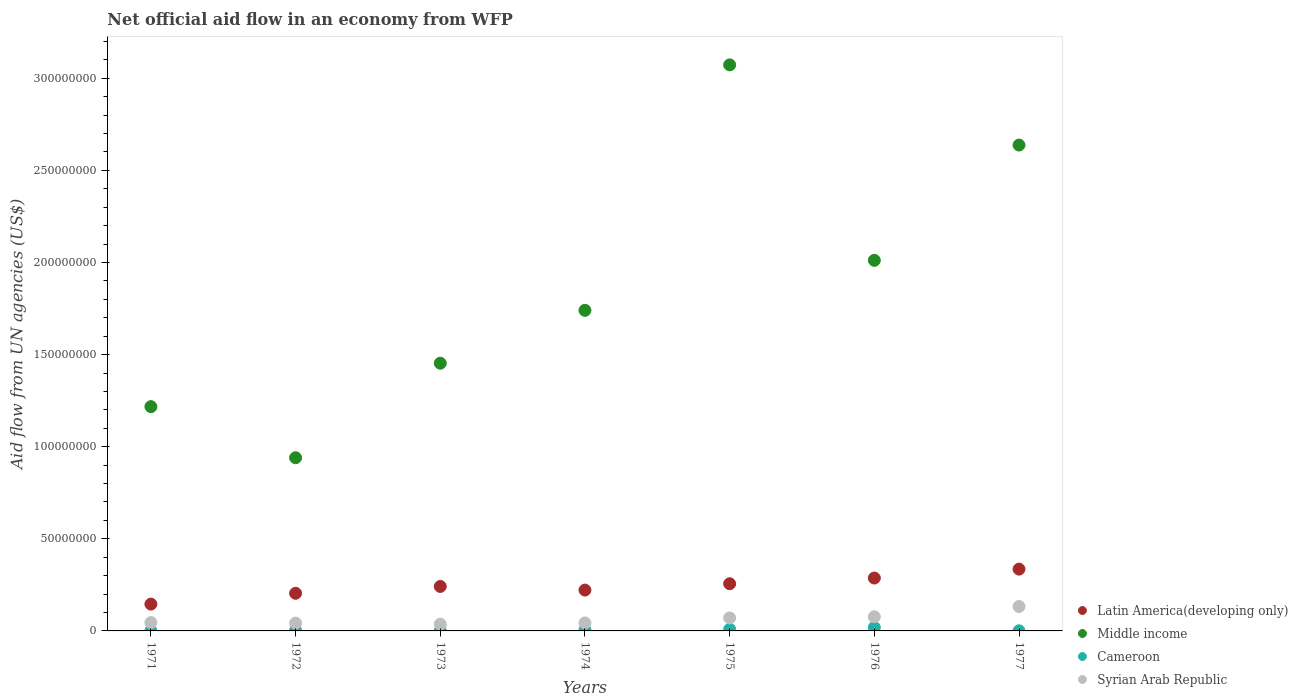How many different coloured dotlines are there?
Your answer should be very brief. 4. Is the number of dotlines equal to the number of legend labels?
Provide a succinct answer. Yes. What is the net official aid flow in Syrian Arab Republic in 1976?
Make the answer very short. 7.68e+06. Across all years, what is the maximum net official aid flow in Middle income?
Your answer should be compact. 3.07e+08. Across all years, what is the minimum net official aid flow in Latin America(developing only)?
Your answer should be very brief. 1.46e+07. In which year was the net official aid flow in Latin America(developing only) minimum?
Your answer should be compact. 1971. What is the total net official aid flow in Middle income in the graph?
Offer a terse response. 1.31e+09. What is the difference between the net official aid flow in Syrian Arab Republic in 1972 and that in 1976?
Offer a terse response. -3.42e+06. What is the difference between the net official aid flow in Syrian Arab Republic in 1975 and the net official aid flow in Cameroon in 1972?
Ensure brevity in your answer.  6.81e+06. What is the average net official aid flow in Syrian Arab Republic per year?
Ensure brevity in your answer.  6.39e+06. In the year 1977, what is the difference between the net official aid flow in Latin America(developing only) and net official aid flow in Cameroon?
Your answer should be compact. 3.35e+07. In how many years, is the net official aid flow in Latin America(developing only) greater than 90000000 US$?
Your answer should be compact. 0. What is the ratio of the net official aid flow in Cameroon in 1972 to that in 1976?
Your response must be concise. 0.13. Is the net official aid flow in Latin America(developing only) in 1976 less than that in 1977?
Offer a terse response. Yes. What is the difference between the highest and the second highest net official aid flow in Syrian Arab Republic?
Offer a very short reply. 5.57e+06. What is the difference between the highest and the lowest net official aid flow in Middle income?
Offer a terse response. 2.13e+08. In how many years, is the net official aid flow in Latin America(developing only) greater than the average net official aid flow in Latin America(developing only) taken over all years?
Provide a succinct answer. 3. Is the net official aid flow in Middle income strictly greater than the net official aid flow in Cameroon over the years?
Offer a terse response. Yes. Is the net official aid flow in Syrian Arab Republic strictly less than the net official aid flow in Middle income over the years?
Keep it short and to the point. Yes. How many dotlines are there?
Make the answer very short. 4. How many years are there in the graph?
Offer a terse response. 7. What is the difference between two consecutive major ticks on the Y-axis?
Your answer should be compact. 5.00e+07. Are the values on the major ticks of Y-axis written in scientific E-notation?
Give a very brief answer. No. Where does the legend appear in the graph?
Ensure brevity in your answer.  Bottom right. What is the title of the graph?
Keep it short and to the point. Net official aid flow in an economy from WFP. What is the label or title of the X-axis?
Ensure brevity in your answer.  Years. What is the label or title of the Y-axis?
Offer a very short reply. Aid flow from UN agencies (US$). What is the Aid flow from UN agencies (US$) in Latin America(developing only) in 1971?
Provide a short and direct response. 1.46e+07. What is the Aid flow from UN agencies (US$) in Middle income in 1971?
Your answer should be compact. 1.22e+08. What is the Aid flow from UN agencies (US$) of Cameroon in 1971?
Offer a very short reply. 9.00e+04. What is the Aid flow from UN agencies (US$) in Syrian Arab Republic in 1971?
Give a very brief answer. 4.53e+06. What is the Aid flow from UN agencies (US$) in Latin America(developing only) in 1972?
Your answer should be compact. 2.04e+07. What is the Aid flow from UN agencies (US$) of Middle income in 1972?
Your answer should be compact. 9.40e+07. What is the Aid flow from UN agencies (US$) of Cameroon in 1972?
Provide a short and direct response. 2.40e+05. What is the Aid flow from UN agencies (US$) in Syrian Arab Republic in 1972?
Offer a very short reply. 4.26e+06. What is the Aid flow from UN agencies (US$) in Latin America(developing only) in 1973?
Give a very brief answer. 2.42e+07. What is the Aid flow from UN agencies (US$) in Middle income in 1973?
Keep it short and to the point. 1.45e+08. What is the Aid flow from UN agencies (US$) in Syrian Arab Republic in 1973?
Ensure brevity in your answer.  3.66e+06. What is the Aid flow from UN agencies (US$) in Latin America(developing only) in 1974?
Ensure brevity in your answer.  2.22e+07. What is the Aid flow from UN agencies (US$) of Middle income in 1974?
Make the answer very short. 1.74e+08. What is the Aid flow from UN agencies (US$) of Cameroon in 1974?
Provide a succinct answer. 5.40e+05. What is the Aid flow from UN agencies (US$) in Syrian Arab Republic in 1974?
Keep it short and to the point. 4.33e+06. What is the Aid flow from UN agencies (US$) in Latin America(developing only) in 1975?
Give a very brief answer. 2.56e+07. What is the Aid flow from UN agencies (US$) in Middle income in 1975?
Give a very brief answer. 3.07e+08. What is the Aid flow from UN agencies (US$) of Cameroon in 1975?
Offer a very short reply. 8.50e+05. What is the Aid flow from UN agencies (US$) of Syrian Arab Republic in 1975?
Provide a short and direct response. 7.05e+06. What is the Aid flow from UN agencies (US$) of Latin America(developing only) in 1976?
Make the answer very short. 2.87e+07. What is the Aid flow from UN agencies (US$) in Middle income in 1976?
Keep it short and to the point. 2.01e+08. What is the Aid flow from UN agencies (US$) of Cameroon in 1976?
Provide a succinct answer. 1.91e+06. What is the Aid flow from UN agencies (US$) in Syrian Arab Republic in 1976?
Make the answer very short. 7.68e+06. What is the Aid flow from UN agencies (US$) in Latin America(developing only) in 1977?
Offer a very short reply. 3.36e+07. What is the Aid flow from UN agencies (US$) of Middle income in 1977?
Your response must be concise. 2.64e+08. What is the Aid flow from UN agencies (US$) of Syrian Arab Republic in 1977?
Keep it short and to the point. 1.32e+07. Across all years, what is the maximum Aid flow from UN agencies (US$) in Latin America(developing only)?
Keep it short and to the point. 3.36e+07. Across all years, what is the maximum Aid flow from UN agencies (US$) in Middle income?
Ensure brevity in your answer.  3.07e+08. Across all years, what is the maximum Aid flow from UN agencies (US$) of Cameroon?
Provide a short and direct response. 1.91e+06. Across all years, what is the maximum Aid flow from UN agencies (US$) of Syrian Arab Republic?
Give a very brief answer. 1.32e+07. Across all years, what is the minimum Aid flow from UN agencies (US$) of Latin America(developing only)?
Ensure brevity in your answer.  1.46e+07. Across all years, what is the minimum Aid flow from UN agencies (US$) in Middle income?
Provide a succinct answer. 9.40e+07. Across all years, what is the minimum Aid flow from UN agencies (US$) of Syrian Arab Republic?
Keep it short and to the point. 3.66e+06. What is the total Aid flow from UN agencies (US$) in Latin America(developing only) in the graph?
Provide a short and direct response. 1.69e+08. What is the total Aid flow from UN agencies (US$) in Middle income in the graph?
Your response must be concise. 1.31e+09. What is the total Aid flow from UN agencies (US$) of Cameroon in the graph?
Offer a terse response. 3.81e+06. What is the total Aid flow from UN agencies (US$) of Syrian Arab Republic in the graph?
Offer a terse response. 4.48e+07. What is the difference between the Aid flow from UN agencies (US$) of Latin America(developing only) in 1971 and that in 1972?
Your answer should be very brief. -5.87e+06. What is the difference between the Aid flow from UN agencies (US$) of Middle income in 1971 and that in 1972?
Make the answer very short. 2.77e+07. What is the difference between the Aid flow from UN agencies (US$) of Syrian Arab Republic in 1971 and that in 1972?
Keep it short and to the point. 2.70e+05. What is the difference between the Aid flow from UN agencies (US$) of Latin America(developing only) in 1971 and that in 1973?
Provide a succinct answer. -9.59e+06. What is the difference between the Aid flow from UN agencies (US$) in Middle income in 1971 and that in 1973?
Offer a very short reply. -2.36e+07. What is the difference between the Aid flow from UN agencies (US$) of Syrian Arab Republic in 1971 and that in 1973?
Your response must be concise. 8.70e+05. What is the difference between the Aid flow from UN agencies (US$) of Latin America(developing only) in 1971 and that in 1974?
Make the answer very short. -7.61e+06. What is the difference between the Aid flow from UN agencies (US$) of Middle income in 1971 and that in 1974?
Your answer should be very brief. -5.23e+07. What is the difference between the Aid flow from UN agencies (US$) in Cameroon in 1971 and that in 1974?
Provide a succinct answer. -4.50e+05. What is the difference between the Aid flow from UN agencies (US$) in Syrian Arab Republic in 1971 and that in 1974?
Make the answer very short. 2.00e+05. What is the difference between the Aid flow from UN agencies (US$) in Latin America(developing only) in 1971 and that in 1975?
Give a very brief answer. -1.11e+07. What is the difference between the Aid flow from UN agencies (US$) of Middle income in 1971 and that in 1975?
Offer a terse response. -1.86e+08. What is the difference between the Aid flow from UN agencies (US$) in Cameroon in 1971 and that in 1975?
Your answer should be compact. -7.60e+05. What is the difference between the Aid flow from UN agencies (US$) in Syrian Arab Republic in 1971 and that in 1975?
Ensure brevity in your answer.  -2.52e+06. What is the difference between the Aid flow from UN agencies (US$) of Latin America(developing only) in 1971 and that in 1976?
Offer a very short reply. -1.42e+07. What is the difference between the Aid flow from UN agencies (US$) of Middle income in 1971 and that in 1976?
Your answer should be compact. -7.94e+07. What is the difference between the Aid flow from UN agencies (US$) in Cameroon in 1971 and that in 1976?
Offer a terse response. -1.82e+06. What is the difference between the Aid flow from UN agencies (US$) in Syrian Arab Republic in 1971 and that in 1976?
Offer a terse response. -3.15e+06. What is the difference between the Aid flow from UN agencies (US$) of Latin America(developing only) in 1971 and that in 1977?
Your response must be concise. -1.90e+07. What is the difference between the Aid flow from UN agencies (US$) of Middle income in 1971 and that in 1977?
Provide a short and direct response. -1.42e+08. What is the difference between the Aid flow from UN agencies (US$) of Cameroon in 1971 and that in 1977?
Give a very brief answer. 3.00e+04. What is the difference between the Aid flow from UN agencies (US$) of Syrian Arab Republic in 1971 and that in 1977?
Your response must be concise. -8.72e+06. What is the difference between the Aid flow from UN agencies (US$) in Latin America(developing only) in 1972 and that in 1973?
Your answer should be very brief. -3.72e+06. What is the difference between the Aid flow from UN agencies (US$) of Middle income in 1972 and that in 1973?
Offer a terse response. -5.13e+07. What is the difference between the Aid flow from UN agencies (US$) in Cameroon in 1972 and that in 1973?
Offer a terse response. 1.20e+05. What is the difference between the Aid flow from UN agencies (US$) of Syrian Arab Republic in 1972 and that in 1973?
Provide a succinct answer. 6.00e+05. What is the difference between the Aid flow from UN agencies (US$) in Latin America(developing only) in 1972 and that in 1974?
Provide a succinct answer. -1.74e+06. What is the difference between the Aid flow from UN agencies (US$) of Middle income in 1972 and that in 1974?
Provide a succinct answer. -8.00e+07. What is the difference between the Aid flow from UN agencies (US$) in Latin America(developing only) in 1972 and that in 1975?
Give a very brief answer. -5.19e+06. What is the difference between the Aid flow from UN agencies (US$) of Middle income in 1972 and that in 1975?
Your response must be concise. -2.13e+08. What is the difference between the Aid flow from UN agencies (US$) of Cameroon in 1972 and that in 1975?
Provide a short and direct response. -6.10e+05. What is the difference between the Aid flow from UN agencies (US$) in Syrian Arab Republic in 1972 and that in 1975?
Provide a succinct answer. -2.79e+06. What is the difference between the Aid flow from UN agencies (US$) in Latin America(developing only) in 1972 and that in 1976?
Offer a terse response. -8.28e+06. What is the difference between the Aid flow from UN agencies (US$) of Middle income in 1972 and that in 1976?
Your response must be concise. -1.07e+08. What is the difference between the Aid flow from UN agencies (US$) of Cameroon in 1972 and that in 1976?
Offer a very short reply. -1.67e+06. What is the difference between the Aid flow from UN agencies (US$) of Syrian Arab Republic in 1972 and that in 1976?
Make the answer very short. -3.42e+06. What is the difference between the Aid flow from UN agencies (US$) of Latin America(developing only) in 1972 and that in 1977?
Your answer should be very brief. -1.31e+07. What is the difference between the Aid flow from UN agencies (US$) in Middle income in 1972 and that in 1977?
Keep it short and to the point. -1.70e+08. What is the difference between the Aid flow from UN agencies (US$) in Cameroon in 1972 and that in 1977?
Offer a very short reply. 1.80e+05. What is the difference between the Aid flow from UN agencies (US$) of Syrian Arab Republic in 1972 and that in 1977?
Your answer should be compact. -8.99e+06. What is the difference between the Aid flow from UN agencies (US$) in Latin America(developing only) in 1973 and that in 1974?
Keep it short and to the point. 1.98e+06. What is the difference between the Aid flow from UN agencies (US$) in Middle income in 1973 and that in 1974?
Give a very brief answer. -2.87e+07. What is the difference between the Aid flow from UN agencies (US$) in Cameroon in 1973 and that in 1974?
Your answer should be very brief. -4.20e+05. What is the difference between the Aid flow from UN agencies (US$) of Syrian Arab Republic in 1973 and that in 1974?
Offer a very short reply. -6.70e+05. What is the difference between the Aid flow from UN agencies (US$) in Latin America(developing only) in 1973 and that in 1975?
Your answer should be very brief. -1.47e+06. What is the difference between the Aid flow from UN agencies (US$) in Middle income in 1973 and that in 1975?
Your answer should be very brief. -1.62e+08. What is the difference between the Aid flow from UN agencies (US$) of Cameroon in 1973 and that in 1975?
Your answer should be compact. -7.30e+05. What is the difference between the Aid flow from UN agencies (US$) of Syrian Arab Republic in 1973 and that in 1975?
Keep it short and to the point. -3.39e+06. What is the difference between the Aid flow from UN agencies (US$) in Latin America(developing only) in 1973 and that in 1976?
Keep it short and to the point. -4.56e+06. What is the difference between the Aid flow from UN agencies (US$) in Middle income in 1973 and that in 1976?
Your answer should be compact. -5.58e+07. What is the difference between the Aid flow from UN agencies (US$) in Cameroon in 1973 and that in 1976?
Provide a short and direct response. -1.79e+06. What is the difference between the Aid flow from UN agencies (US$) in Syrian Arab Republic in 1973 and that in 1976?
Give a very brief answer. -4.02e+06. What is the difference between the Aid flow from UN agencies (US$) of Latin America(developing only) in 1973 and that in 1977?
Make the answer very short. -9.40e+06. What is the difference between the Aid flow from UN agencies (US$) of Middle income in 1973 and that in 1977?
Your answer should be very brief. -1.18e+08. What is the difference between the Aid flow from UN agencies (US$) in Cameroon in 1973 and that in 1977?
Give a very brief answer. 6.00e+04. What is the difference between the Aid flow from UN agencies (US$) in Syrian Arab Republic in 1973 and that in 1977?
Your answer should be compact. -9.59e+06. What is the difference between the Aid flow from UN agencies (US$) of Latin America(developing only) in 1974 and that in 1975?
Provide a short and direct response. -3.45e+06. What is the difference between the Aid flow from UN agencies (US$) in Middle income in 1974 and that in 1975?
Your answer should be very brief. -1.33e+08. What is the difference between the Aid flow from UN agencies (US$) in Cameroon in 1974 and that in 1975?
Provide a succinct answer. -3.10e+05. What is the difference between the Aid flow from UN agencies (US$) in Syrian Arab Republic in 1974 and that in 1975?
Your response must be concise. -2.72e+06. What is the difference between the Aid flow from UN agencies (US$) of Latin America(developing only) in 1974 and that in 1976?
Provide a short and direct response. -6.54e+06. What is the difference between the Aid flow from UN agencies (US$) in Middle income in 1974 and that in 1976?
Provide a succinct answer. -2.72e+07. What is the difference between the Aid flow from UN agencies (US$) of Cameroon in 1974 and that in 1976?
Provide a succinct answer. -1.37e+06. What is the difference between the Aid flow from UN agencies (US$) of Syrian Arab Republic in 1974 and that in 1976?
Your answer should be compact. -3.35e+06. What is the difference between the Aid flow from UN agencies (US$) of Latin America(developing only) in 1974 and that in 1977?
Offer a terse response. -1.14e+07. What is the difference between the Aid flow from UN agencies (US$) in Middle income in 1974 and that in 1977?
Provide a short and direct response. -8.97e+07. What is the difference between the Aid flow from UN agencies (US$) of Syrian Arab Republic in 1974 and that in 1977?
Your answer should be compact. -8.92e+06. What is the difference between the Aid flow from UN agencies (US$) in Latin America(developing only) in 1975 and that in 1976?
Give a very brief answer. -3.09e+06. What is the difference between the Aid flow from UN agencies (US$) of Middle income in 1975 and that in 1976?
Keep it short and to the point. 1.06e+08. What is the difference between the Aid flow from UN agencies (US$) in Cameroon in 1975 and that in 1976?
Make the answer very short. -1.06e+06. What is the difference between the Aid flow from UN agencies (US$) of Syrian Arab Republic in 1975 and that in 1976?
Offer a terse response. -6.30e+05. What is the difference between the Aid flow from UN agencies (US$) in Latin America(developing only) in 1975 and that in 1977?
Provide a short and direct response. -7.93e+06. What is the difference between the Aid flow from UN agencies (US$) of Middle income in 1975 and that in 1977?
Give a very brief answer. 4.35e+07. What is the difference between the Aid flow from UN agencies (US$) of Cameroon in 1975 and that in 1977?
Your answer should be compact. 7.90e+05. What is the difference between the Aid flow from UN agencies (US$) of Syrian Arab Republic in 1975 and that in 1977?
Provide a succinct answer. -6.20e+06. What is the difference between the Aid flow from UN agencies (US$) in Latin America(developing only) in 1976 and that in 1977?
Keep it short and to the point. -4.84e+06. What is the difference between the Aid flow from UN agencies (US$) in Middle income in 1976 and that in 1977?
Ensure brevity in your answer.  -6.26e+07. What is the difference between the Aid flow from UN agencies (US$) of Cameroon in 1976 and that in 1977?
Your response must be concise. 1.85e+06. What is the difference between the Aid flow from UN agencies (US$) of Syrian Arab Republic in 1976 and that in 1977?
Your answer should be compact. -5.57e+06. What is the difference between the Aid flow from UN agencies (US$) in Latin America(developing only) in 1971 and the Aid flow from UN agencies (US$) in Middle income in 1972?
Your answer should be very brief. -7.95e+07. What is the difference between the Aid flow from UN agencies (US$) of Latin America(developing only) in 1971 and the Aid flow from UN agencies (US$) of Cameroon in 1972?
Your answer should be compact. 1.43e+07. What is the difference between the Aid flow from UN agencies (US$) in Latin America(developing only) in 1971 and the Aid flow from UN agencies (US$) in Syrian Arab Republic in 1972?
Provide a succinct answer. 1.03e+07. What is the difference between the Aid flow from UN agencies (US$) in Middle income in 1971 and the Aid flow from UN agencies (US$) in Cameroon in 1972?
Your answer should be compact. 1.22e+08. What is the difference between the Aid flow from UN agencies (US$) of Middle income in 1971 and the Aid flow from UN agencies (US$) of Syrian Arab Republic in 1972?
Your answer should be compact. 1.17e+08. What is the difference between the Aid flow from UN agencies (US$) of Cameroon in 1971 and the Aid flow from UN agencies (US$) of Syrian Arab Republic in 1972?
Give a very brief answer. -4.17e+06. What is the difference between the Aid flow from UN agencies (US$) of Latin America(developing only) in 1971 and the Aid flow from UN agencies (US$) of Middle income in 1973?
Your answer should be compact. -1.31e+08. What is the difference between the Aid flow from UN agencies (US$) in Latin America(developing only) in 1971 and the Aid flow from UN agencies (US$) in Cameroon in 1973?
Ensure brevity in your answer.  1.44e+07. What is the difference between the Aid flow from UN agencies (US$) in Latin America(developing only) in 1971 and the Aid flow from UN agencies (US$) in Syrian Arab Republic in 1973?
Make the answer very short. 1.09e+07. What is the difference between the Aid flow from UN agencies (US$) in Middle income in 1971 and the Aid flow from UN agencies (US$) in Cameroon in 1973?
Keep it short and to the point. 1.22e+08. What is the difference between the Aid flow from UN agencies (US$) of Middle income in 1971 and the Aid flow from UN agencies (US$) of Syrian Arab Republic in 1973?
Provide a short and direct response. 1.18e+08. What is the difference between the Aid flow from UN agencies (US$) in Cameroon in 1971 and the Aid flow from UN agencies (US$) in Syrian Arab Republic in 1973?
Your answer should be compact. -3.57e+06. What is the difference between the Aid flow from UN agencies (US$) of Latin America(developing only) in 1971 and the Aid flow from UN agencies (US$) of Middle income in 1974?
Make the answer very short. -1.59e+08. What is the difference between the Aid flow from UN agencies (US$) in Latin America(developing only) in 1971 and the Aid flow from UN agencies (US$) in Cameroon in 1974?
Make the answer very short. 1.40e+07. What is the difference between the Aid flow from UN agencies (US$) of Latin America(developing only) in 1971 and the Aid flow from UN agencies (US$) of Syrian Arab Republic in 1974?
Ensure brevity in your answer.  1.02e+07. What is the difference between the Aid flow from UN agencies (US$) of Middle income in 1971 and the Aid flow from UN agencies (US$) of Cameroon in 1974?
Offer a very short reply. 1.21e+08. What is the difference between the Aid flow from UN agencies (US$) in Middle income in 1971 and the Aid flow from UN agencies (US$) in Syrian Arab Republic in 1974?
Keep it short and to the point. 1.17e+08. What is the difference between the Aid flow from UN agencies (US$) in Cameroon in 1971 and the Aid flow from UN agencies (US$) in Syrian Arab Republic in 1974?
Provide a succinct answer. -4.24e+06. What is the difference between the Aid flow from UN agencies (US$) in Latin America(developing only) in 1971 and the Aid flow from UN agencies (US$) in Middle income in 1975?
Keep it short and to the point. -2.93e+08. What is the difference between the Aid flow from UN agencies (US$) of Latin America(developing only) in 1971 and the Aid flow from UN agencies (US$) of Cameroon in 1975?
Give a very brief answer. 1.37e+07. What is the difference between the Aid flow from UN agencies (US$) in Latin America(developing only) in 1971 and the Aid flow from UN agencies (US$) in Syrian Arab Republic in 1975?
Provide a succinct answer. 7.51e+06. What is the difference between the Aid flow from UN agencies (US$) of Middle income in 1971 and the Aid flow from UN agencies (US$) of Cameroon in 1975?
Give a very brief answer. 1.21e+08. What is the difference between the Aid flow from UN agencies (US$) in Middle income in 1971 and the Aid flow from UN agencies (US$) in Syrian Arab Republic in 1975?
Give a very brief answer. 1.15e+08. What is the difference between the Aid flow from UN agencies (US$) of Cameroon in 1971 and the Aid flow from UN agencies (US$) of Syrian Arab Republic in 1975?
Offer a very short reply. -6.96e+06. What is the difference between the Aid flow from UN agencies (US$) in Latin America(developing only) in 1971 and the Aid flow from UN agencies (US$) in Middle income in 1976?
Offer a very short reply. -1.87e+08. What is the difference between the Aid flow from UN agencies (US$) of Latin America(developing only) in 1971 and the Aid flow from UN agencies (US$) of Cameroon in 1976?
Make the answer very short. 1.26e+07. What is the difference between the Aid flow from UN agencies (US$) of Latin America(developing only) in 1971 and the Aid flow from UN agencies (US$) of Syrian Arab Republic in 1976?
Keep it short and to the point. 6.88e+06. What is the difference between the Aid flow from UN agencies (US$) in Middle income in 1971 and the Aid flow from UN agencies (US$) in Cameroon in 1976?
Give a very brief answer. 1.20e+08. What is the difference between the Aid flow from UN agencies (US$) of Middle income in 1971 and the Aid flow from UN agencies (US$) of Syrian Arab Republic in 1976?
Offer a very short reply. 1.14e+08. What is the difference between the Aid flow from UN agencies (US$) of Cameroon in 1971 and the Aid flow from UN agencies (US$) of Syrian Arab Republic in 1976?
Provide a succinct answer. -7.59e+06. What is the difference between the Aid flow from UN agencies (US$) of Latin America(developing only) in 1971 and the Aid flow from UN agencies (US$) of Middle income in 1977?
Your answer should be compact. -2.49e+08. What is the difference between the Aid flow from UN agencies (US$) of Latin America(developing only) in 1971 and the Aid flow from UN agencies (US$) of Cameroon in 1977?
Offer a very short reply. 1.45e+07. What is the difference between the Aid flow from UN agencies (US$) in Latin America(developing only) in 1971 and the Aid flow from UN agencies (US$) in Syrian Arab Republic in 1977?
Offer a very short reply. 1.31e+06. What is the difference between the Aid flow from UN agencies (US$) of Middle income in 1971 and the Aid flow from UN agencies (US$) of Cameroon in 1977?
Provide a short and direct response. 1.22e+08. What is the difference between the Aid flow from UN agencies (US$) of Middle income in 1971 and the Aid flow from UN agencies (US$) of Syrian Arab Republic in 1977?
Offer a very short reply. 1.08e+08. What is the difference between the Aid flow from UN agencies (US$) of Cameroon in 1971 and the Aid flow from UN agencies (US$) of Syrian Arab Republic in 1977?
Give a very brief answer. -1.32e+07. What is the difference between the Aid flow from UN agencies (US$) of Latin America(developing only) in 1972 and the Aid flow from UN agencies (US$) of Middle income in 1973?
Your answer should be compact. -1.25e+08. What is the difference between the Aid flow from UN agencies (US$) of Latin America(developing only) in 1972 and the Aid flow from UN agencies (US$) of Cameroon in 1973?
Provide a short and direct response. 2.03e+07. What is the difference between the Aid flow from UN agencies (US$) in Latin America(developing only) in 1972 and the Aid flow from UN agencies (US$) in Syrian Arab Republic in 1973?
Provide a succinct answer. 1.68e+07. What is the difference between the Aid flow from UN agencies (US$) of Middle income in 1972 and the Aid flow from UN agencies (US$) of Cameroon in 1973?
Keep it short and to the point. 9.39e+07. What is the difference between the Aid flow from UN agencies (US$) of Middle income in 1972 and the Aid flow from UN agencies (US$) of Syrian Arab Republic in 1973?
Offer a terse response. 9.04e+07. What is the difference between the Aid flow from UN agencies (US$) in Cameroon in 1972 and the Aid flow from UN agencies (US$) in Syrian Arab Republic in 1973?
Give a very brief answer. -3.42e+06. What is the difference between the Aid flow from UN agencies (US$) in Latin America(developing only) in 1972 and the Aid flow from UN agencies (US$) in Middle income in 1974?
Give a very brief answer. -1.54e+08. What is the difference between the Aid flow from UN agencies (US$) of Latin America(developing only) in 1972 and the Aid flow from UN agencies (US$) of Cameroon in 1974?
Give a very brief answer. 1.99e+07. What is the difference between the Aid flow from UN agencies (US$) in Latin America(developing only) in 1972 and the Aid flow from UN agencies (US$) in Syrian Arab Republic in 1974?
Keep it short and to the point. 1.61e+07. What is the difference between the Aid flow from UN agencies (US$) of Middle income in 1972 and the Aid flow from UN agencies (US$) of Cameroon in 1974?
Offer a very short reply. 9.35e+07. What is the difference between the Aid flow from UN agencies (US$) of Middle income in 1972 and the Aid flow from UN agencies (US$) of Syrian Arab Republic in 1974?
Offer a terse response. 8.97e+07. What is the difference between the Aid flow from UN agencies (US$) in Cameroon in 1972 and the Aid flow from UN agencies (US$) in Syrian Arab Republic in 1974?
Make the answer very short. -4.09e+06. What is the difference between the Aid flow from UN agencies (US$) in Latin America(developing only) in 1972 and the Aid flow from UN agencies (US$) in Middle income in 1975?
Give a very brief answer. -2.87e+08. What is the difference between the Aid flow from UN agencies (US$) of Latin America(developing only) in 1972 and the Aid flow from UN agencies (US$) of Cameroon in 1975?
Your answer should be compact. 1.96e+07. What is the difference between the Aid flow from UN agencies (US$) in Latin America(developing only) in 1972 and the Aid flow from UN agencies (US$) in Syrian Arab Republic in 1975?
Offer a terse response. 1.34e+07. What is the difference between the Aid flow from UN agencies (US$) in Middle income in 1972 and the Aid flow from UN agencies (US$) in Cameroon in 1975?
Provide a short and direct response. 9.32e+07. What is the difference between the Aid flow from UN agencies (US$) in Middle income in 1972 and the Aid flow from UN agencies (US$) in Syrian Arab Republic in 1975?
Give a very brief answer. 8.70e+07. What is the difference between the Aid flow from UN agencies (US$) of Cameroon in 1972 and the Aid flow from UN agencies (US$) of Syrian Arab Republic in 1975?
Ensure brevity in your answer.  -6.81e+06. What is the difference between the Aid flow from UN agencies (US$) in Latin America(developing only) in 1972 and the Aid flow from UN agencies (US$) in Middle income in 1976?
Offer a terse response. -1.81e+08. What is the difference between the Aid flow from UN agencies (US$) of Latin America(developing only) in 1972 and the Aid flow from UN agencies (US$) of Cameroon in 1976?
Your answer should be very brief. 1.85e+07. What is the difference between the Aid flow from UN agencies (US$) of Latin America(developing only) in 1972 and the Aid flow from UN agencies (US$) of Syrian Arab Republic in 1976?
Provide a succinct answer. 1.28e+07. What is the difference between the Aid flow from UN agencies (US$) in Middle income in 1972 and the Aid flow from UN agencies (US$) in Cameroon in 1976?
Ensure brevity in your answer.  9.21e+07. What is the difference between the Aid flow from UN agencies (US$) in Middle income in 1972 and the Aid flow from UN agencies (US$) in Syrian Arab Republic in 1976?
Keep it short and to the point. 8.63e+07. What is the difference between the Aid flow from UN agencies (US$) in Cameroon in 1972 and the Aid flow from UN agencies (US$) in Syrian Arab Republic in 1976?
Provide a short and direct response. -7.44e+06. What is the difference between the Aid flow from UN agencies (US$) of Latin America(developing only) in 1972 and the Aid flow from UN agencies (US$) of Middle income in 1977?
Your response must be concise. -2.43e+08. What is the difference between the Aid flow from UN agencies (US$) of Latin America(developing only) in 1972 and the Aid flow from UN agencies (US$) of Cameroon in 1977?
Give a very brief answer. 2.04e+07. What is the difference between the Aid flow from UN agencies (US$) of Latin America(developing only) in 1972 and the Aid flow from UN agencies (US$) of Syrian Arab Republic in 1977?
Your answer should be compact. 7.18e+06. What is the difference between the Aid flow from UN agencies (US$) of Middle income in 1972 and the Aid flow from UN agencies (US$) of Cameroon in 1977?
Give a very brief answer. 9.40e+07. What is the difference between the Aid flow from UN agencies (US$) of Middle income in 1972 and the Aid flow from UN agencies (US$) of Syrian Arab Republic in 1977?
Your answer should be compact. 8.08e+07. What is the difference between the Aid flow from UN agencies (US$) of Cameroon in 1972 and the Aid flow from UN agencies (US$) of Syrian Arab Republic in 1977?
Your response must be concise. -1.30e+07. What is the difference between the Aid flow from UN agencies (US$) in Latin America(developing only) in 1973 and the Aid flow from UN agencies (US$) in Middle income in 1974?
Keep it short and to the point. -1.50e+08. What is the difference between the Aid flow from UN agencies (US$) of Latin America(developing only) in 1973 and the Aid flow from UN agencies (US$) of Cameroon in 1974?
Ensure brevity in your answer.  2.36e+07. What is the difference between the Aid flow from UN agencies (US$) in Latin America(developing only) in 1973 and the Aid flow from UN agencies (US$) in Syrian Arab Republic in 1974?
Make the answer very short. 1.98e+07. What is the difference between the Aid flow from UN agencies (US$) in Middle income in 1973 and the Aid flow from UN agencies (US$) in Cameroon in 1974?
Provide a succinct answer. 1.45e+08. What is the difference between the Aid flow from UN agencies (US$) in Middle income in 1973 and the Aid flow from UN agencies (US$) in Syrian Arab Republic in 1974?
Make the answer very short. 1.41e+08. What is the difference between the Aid flow from UN agencies (US$) in Cameroon in 1973 and the Aid flow from UN agencies (US$) in Syrian Arab Republic in 1974?
Ensure brevity in your answer.  -4.21e+06. What is the difference between the Aid flow from UN agencies (US$) of Latin America(developing only) in 1973 and the Aid flow from UN agencies (US$) of Middle income in 1975?
Ensure brevity in your answer.  -2.83e+08. What is the difference between the Aid flow from UN agencies (US$) of Latin America(developing only) in 1973 and the Aid flow from UN agencies (US$) of Cameroon in 1975?
Ensure brevity in your answer.  2.33e+07. What is the difference between the Aid flow from UN agencies (US$) in Latin America(developing only) in 1973 and the Aid flow from UN agencies (US$) in Syrian Arab Republic in 1975?
Provide a succinct answer. 1.71e+07. What is the difference between the Aid flow from UN agencies (US$) in Middle income in 1973 and the Aid flow from UN agencies (US$) in Cameroon in 1975?
Your response must be concise. 1.44e+08. What is the difference between the Aid flow from UN agencies (US$) in Middle income in 1973 and the Aid flow from UN agencies (US$) in Syrian Arab Republic in 1975?
Keep it short and to the point. 1.38e+08. What is the difference between the Aid flow from UN agencies (US$) in Cameroon in 1973 and the Aid flow from UN agencies (US$) in Syrian Arab Republic in 1975?
Provide a short and direct response. -6.93e+06. What is the difference between the Aid flow from UN agencies (US$) of Latin America(developing only) in 1973 and the Aid flow from UN agencies (US$) of Middle income in 1976?
Your answer should be very brief. -1.77e+08. What is the difference between the Aid flow from UN agencies (US$) in Latin America(developing only) in 1973 and the Aid flow from UN agencies (US$) in Cameroon in 1976?
Give a very brief answer. 2.22e+07. What is the difference between the Aid flow from UN agencies (US$) of Latin America(developing only) in 1973 and the Aid flow from UN agencies (US$) of Syrian Arab Republic in 1976?
Provide a succinct answer. 1.65e+07. What is the difference between the Aid flow from UN agencies (US$) in Middle income in 1973 and the Aid flow from UN agencies (US$) in Cameroon in 1976?
Provide a short and direct response. 1.43e+08. What is the difference between the Aid flow from UN agencies (US$) in Middle income in 1973 and the Aid flow from UN agencies (US$) in Syrian Arab Republic in 1976?
Ensure brevity in your answer.  1.38e+08. What is the difference between the Aid flow from UN agencies (US$) of Cameroon in 1973 and the Aid flow from UN agencies (US$) of Syrian Arab Republic in 1976?
Your answer should be very brief. -7.56e+06. What is the difference between the Aid flow from UN agencies (US$) of Latin America(developing only) in 1973 and the Aid flow from UN agencies (US$) of Middle income in 1977?
Provide a short and direct response. -2.40e+08. What is the difference between the Aid flow from UN agencies (US$) of Latin America(developing only) in 1973 and the Aid flow from UN agencies (US$) of Cameroon in 1977?
Offer a very short reply. 2.41e+07. What is the difference between the Aid flow from UN agencies (US$) in Latin America(developing only) in 1973 and the Aid flow from UN agencies (US$) in Syrian Arab Republic in 1977?
Provide a short and direct response. 1.09e+07. What is the difference between the Aid flow from UN agencies (US$) in Middle income in 1973 and the Aid flow from UN agencies (US$) in Cameroon in 1977?
Keep it short and to the point. 1.45e+08. What is the difference between the Aid flow from UN agencies (US$) of Middle income in 1973 and the Aid flow from UN agencies (US$) of Syrian Arab Republic in 1977?
Provide a succinct answer. 1.32e+08. What is the difference between the Aid flow from UN agencies (US$) in Cameroon in 1973 and the Aid flow from UN agencies (US$) in Syrian Arab Republic in 1977?
Provide a succinct answer. -1.31e+07. What is the difference between the Aid flow from UN agencies (US$) in Latin America(developing only) in 1974 and the Aid flow from UN agencies (US$) in Middle income in 1975?
Your answer should be very brief. -2.85e+08. What is the difference between the Aid flow from UN agencies (US$) in Latin America(developing only) in 1974 and the Aid flow from UN agencies (US$) in Cameroon in 1975?
Your response must be concise. 2.13e+07. What is the difference between the Aid flow from UN agencies (US$) in Latin America(developing only) in 1974 and the Aid flow from UN agencies (US$) in Syrian Arab Republic in 1975?
Offer a very short reply. 1.51e+07. What is the difference between the Aid flow from UN agencies (US$) of Middle income in 1974 and the Aid flow from UN agencies (US$) of Cameroon in 1975?
Your answer should be very brief. 1.73e+08. What is the difference between the Aid flow from UN agencies (US$) in Middle income in 1974 and the Aid flow from UN agencies (US$) in Syrian Arab Republic in 1975?
Make the answer very short. 1.67e+08. What is the difference between the Aid flow from UN agencies (US$) of Cameroon in 1974 and the Aid flow from UN agencies (US$) of Syrian Arab Republic in 1975?
Offer a terse response. -6.51e+06. What is the difference between the Aid flow from UN agencies (US$) of Latin America(developing only) in 1974 and the Aid flow from UN agencies (US$) of Middle income in 1976?
Your response must be concise. -1.79e+08. What is the difference between the Aid flow from UN agencies (US$) in Latin America(developing only) in 1974 and the Aid flow from UN agencies (US$) in Cameroon in 1976?
Keep it short and to the point. 2.03e+07. What is the difference between the Aid flow from UN agencies (US$) in Latin America(developing only) in 1974 and the Aid flow from UN agencies (US$) in Syrian Arab Republic in 1976?
Provide a succinct answer. 1.45e+07. What is the difference between the Aid flow from UN agencies (US$) in Middle income in 1974 and the Aid flow from UN agencies (US$) in Cameroon in 1976?
Give a very brief answer. 1.72e+08. What is the difference between the Aid flow from UN agencies (US$) of Middle income in 1974 and the Aid flow from UN agencies (US$) of Syrian Arab Republic in 1976?
Give a very brief answer. 1.66e+08. What is the difference between the Aid flow from UN agencies (US$) in Cameroon in 1974 and the Aid flow from UN agencies (US$) in Syrian Arab Republic in 1976?
Offer a terse response. -7.14e+06. What is the difference between the Aid flow from UN agencies (US$) in Latin America(developing only) in 1974 and the Aid flow from UN agencies (US$) in Middle income in 1977?
Offer a terse response. -2.42e+08. What is the difference between the Aid flow from UN agencies (US$) in Latin America(developing only) in 1974 and the Aid flow from UN agencies (US$) in Cameroon in 1977?
Offer a very short reply. 2.21e+07. What is the difference between the Aid flow from UN agencies (US$) of Latin America(developing only) in 1974 and the Aid flow from UN agencies (US$) of Syrian Arab Republic in 1977?
Give a very brief answer. 8.92e+06. What is the difference between the Aid flow from UN agencies (US$) in Middle income in 1974 and the Aid flow from UN agencies (US$) in Cameroon in 1977?
Provide a short and direct response. 1.74e+08. What is the difference between the Aid flow from UN agencies (US$) in Middle income in 1974 and the Aid flow from UN agencies (US$) in Syrian Arab Republic in 1977?
Provide a succinct answer. 1.61e+08. What is the difference between the Aid flow from UN agencies (US$) of Cameroon in 1974 and the Aid flow from UN agencies (US$) of Syrian Arab Republic in 1977?
Your answer should be compact. -1.27e+07. What is the difference between the Aid flow from UN agencies (US$) in Latin America(developing only) in 1975 and the Aid flow from UN agencies (US$) in Middle income in 1976?
Your answer should be compact. -1.76e+08. What is the difference between the Aid flow from UN agencies (US$) in Latin America(developing only) in 1975 and the Aid flow from UN agencies (US$) in Cameroon in 1976?
Offer a terse response. 2.37e+07. What is the difference between the Aid flow from UN agencies (US$) in Latin America(developing only) in 1975 and the Aid flow from UN agencies (US$) in Syrian Arab Republic in 1976?
Provide a short and direct response. 1.79e+07. What is the difference between the Aid flow from UN agencies (US$) of Middle income in 1975 and the Aid flow from UN agencies (US$) of Cameroon in 1976?
Provide a short and direct response. 3.05e+08. What is the difference between the Aid flow from UN agencies (US$) in Middle income in 1975 and the Aid flow from UN agencies (US$) in Syrian Arab Republic in 1976?
Make the answer very short. 3.00e+08. What is the difference between the Aid flow from UN agencies (US$) of Cameroon in 1975 and the Aid flow from UN agencies (US$) of Syrian Arab Republic in 1976?
Keep it short and to the point. -6.83e+06. What is the difference between the Aid flow from UN agencies (US$) of Latin America(developing only) in 1975 and the Aid flow from UN agencies (US$) of Middle income in 1977?
Provide a short and direct response. -2.38e+08. What is the difference between the Aid flow from UN agencies (US$) in Latin America(developing only) in 1975 and the Aid flow from UN agencies (US$) in Cameroon in 1977?
Provide a succinct answer. 2.56e+07. What is the difference between the Aid flow from UN agencies (US$) in Latin America(developing only) in 1975 and the Aid flow from UN agencies (US$) in Syrian Arab Republic in 1977?
Provide a short and direct response. 1.24e+07. What is the difference between the Aid flow from UN agencies (US$) in Middle income in 1975 and the Aid flow from UN agencies (US$) in Cameroon in 1977?
Ensure brevity in your answer.  3.07e+08. What is the difference between the Aid flow from UN agencies (US$) in Middle income in 1975 and the Aid flow from UN agencies (US$) in Syrian Arab Republic in 1977?
Your answer should be compact. 2.94e+08. What is the difference between the Aid flow from UN agencies (US$) in Cameroon in 1975 and the Aid flow from UN agencies (US$) in Syrian Arab Republic in 1977?
Keep it short and to the point. -1.24e+07. What is the difference between the Aid flow from UN agencies (US$) in Latin America(developing only) in 1976 and the Aid flow from UN agencies (US$) in Middle income in 1977?
Provide a short and direct response. -2.35e+08. What is the difference between the Aid flow from UN agencies (US$) in Latin America(developing only) in 1976 and the Aid flow from UN agencies (US$) in Cameroon in 1977?
Offer a terse response. 2.86e+07. What is the difference between the Aid flow from UN agencies (US$) in Latin America(developing only) in 1976 and the Aid flow from UN agencies (US$) in Syrian Arab Republic in 1977?
Ensure brevity in your answer.  1.55e+07. What is the difference between the Aid flow from UN agencies (US$) of Middle income in 1976 and the Aid flow from UN agencies (US$) of Cameroon in 1977?
Provide a short and direct response. 2.01e+08. What is the difference between the Aid flow from UN agencies (US$) of Middle income in 1976 and the Aid flow from UN agencies (US$) of Syrian Arab Republic in 1977?
Your answer should be compact. 1.88e+08. What is the difference between the Aid flow from UN agencies (US$) of Cameroon in 1976 and the Aid flow from UN agencies (US$) of Syrian Arab Republic in 1977?
Keep it short and to the point. -1.13e+07. What is the average Aid flow from UN agencies (US$) of Latin America(developing only) per year?
Provide a succinct answer. 2.42e+07. What is the average Aid flow from UN agencies (US$) of Middle income per year?
Offer a very short reply. 1.87e+08. What is the average Aid flow from UN agencies (US$) in Cameroon per year?
Ensure brevity in your answer.  5.44e+05. What is the average Aid flow from UN agencies (US$) of Syrian Arab Republic per year?
Provide a succinct answer. 6.39e+06. In the year 1971, what is the difference between the Aid flow from UN agencies (US$) in Latin America(developing only) and Aid flow from UN agencies (US$) in Middle income?
Your response must be concise. -1.07e+08. In the year 1971, what is the difference between the Aid flow from UN agencies (US$) in Latin America(developing only) and Aid flow from UN agencies (US$) in Cameroon?
Your response must be concise. 1.45e+07. In the year 1971, what is the difference between the Aid flow from UN agencies (US$) of Latin America(developing only) and Aid flow from UN agencies (US$) of Syrian Arab Republic?
Give a very brief answer. 1.00e+07. In the year 1971, what is the difference between the Aid flow from UN agencies (US$) in Middle income and Aid flow from UN agencies (US$) in Cameroon?
Your answer should be compact. 1.22e+08. In the year 1971, what is the difference between the Aid flow from UN agencies (US$) of Middle income and Aid flow from UN agencies (US$) of Syrian Arab Republic?
Your answer should be very brief. 1.17e+08. In the year 1971, what is the difference between the Aid flow from UN agencies (US$) of Cameroon and Aid flow from UN agencies (US$) of Syrian Arab Republic?
Ensure brevity in your answer.  -4.44e+06. In the year 1972, what is the difference between the Aid flow from UN agencies (US$) in Latin America(developing only) and Aid flow from UN agencies (US$) in Middle income?
Ensure brevity in your answer.  -7.36e+07. In the year 1972, what is the difference between the Aid flow from UN agencies (US$) in Latin America(developing only) and Aid flow from UN agencies (US$) in Cameroon?
Make the answer very short. 2.02e+07. In the year 1972, what is the difference between the Aid flow from UN agencies (US$) of Latin America(developing only) and Aid flow from UN agencies (US$) of Syrian Arab Republic?
Provide a succinct answer. 1.62e+07. In the year 1972, what is the difference between the Aid flow from UN agencies (US$) in Middle income and Aid flow from UN agencies (US$) in Cameroon?
Ensure brevity in your answer.  9.38e+07. In the year 1972, what is the difference between the Aid flow from UN agencies (US$) of Middle income and Aid flow from UN agencies (US$) of Syrian Arab Republic?
Offer a terse response. 8.98e+07. In the year 1972, what is the difference between the Aid flow from UN agencies (US$) in Cameroon and Aid flow from UN agencies (US$) in Syrian Arab Republic?
Provide a short and direct response. -4.02e+06. In the year 1973, what is the difference between the Aid flow from UN agencies (US$) of Latin America(developing only) and Aid flow from UN agencies (US$) of Middle income?
Offer a terse response. -1.21e+08. In the year 1973, what is the difference between the Aid flow from UN agencies (US$) in Latin America(developing only) and Aid flow from UN agencies (US$) in Cameroon?
Your answer should be compact. 2.40e+07. In the year 1973, what is the difference between the Aid flow from UN agencies (US$) of Latin America(developing only) and Aid flow from UN agencies (US$) of Syrian Arab Republic?
Your answer should be compact. 2.05e+07. In the year 1973, what is the difference between the Aid flow from UN agencies (US$) of Middle income and Aid flow from UN agencies (US$) of Cameroon?
Offer a very short reply. 1.45e+08. In the year 1973, what is the difference between the Aid flow from UN agencies (US$) of Middle income and Aid flow from UN agencies (US$) of Syrian Arab Republic?
Make the answer very short. 1.42e+08. In the year 1973, what is the difference between the Aid flow from UN agencies (US$) in Cameroon and Aid flow from UN agencies (US$) in Syrian Arab Republic?
Make the answer very short. -3.54e+06. In the year 1974, what is the difference between the Aid flow from UN agencies (US$) of Latin America(developing only) and Aid flow from UN agencies (US$) of Middle income?
Offer a terse response. -1.52e+08. In the year 1974, what is the difference between the Aid flow from UN agencies (US$) of Latin America(developing only) and Aid flow from UN agencies (US$) of Cameroon?
Offer a very short reply. 2.16e+07. In the year 1974, what is the difference between the Aid flow from UN agencies (US$) of Latin America(developing only) and Aid flow from UN agencies (US$) of Syrian Arab Republic?
Your response must be concise. 1.78e+07. In the year 1974, what is the difference between the Aid flow from UN agencies (US$) in Middle income and Aid flow from UN agencies (US$) in Cameroon?
Provide a short and direct response. 1.73e+08. In the year 1974, what is the difference between the Aid flow from UN agencies (US$) of Middle income and Aid flow from UN agencies (US$) of Syrian Arab Republic?
Offer a terse response. 1.70e+08. In the year 1974, what is the difference between the Aid flow from UN agencies (US$) of Cameroon and Aid flow from UN agencies (US$) of Syrian Arab Republic?
Make the answer very short. -3.79e+06. In the year 1975, what is the difference between the Aid flow from UN agencies (US$) in Latin America(developing only) and Aid flow from UN agencies (US$) in Middle income?
Your response must be concise. -2.82e+08. In the year 1975, what is the difference between the Aid flow from UN agencies (US$) of Latin America(developing only) and Aid flow from UN agencies (US$) of Cameroon?
Keep it short and to the point. 2.48e+07. In the year 1975, what is the difference between the Aid flow from UN agencies (US$) in Latin America(developing only) and Aid flow from UN agencies (US$) in Syrian Arab Republic?
Provide a short and direct response. 1.86e+07. In the year 1975, what is the difference between the Aid flow from UN agencies (US$) of Middle income and Aid flow from UN agencies (US$) of Cameroon?
Your response must be concise. 3.06e+08. In the year 1975, what is the difference between the Aid flow from UN agencies (US$) in Middle income and Aid flow from UN agencies (US$) in Syrian Arab Republic?
Keep it short and to the point. 3.00e+08. In the year 1975, what is the difference between the Aid flow from UN agencies (US$) of Cameroon and Aid flow from UN agencies (US$) of Syrian Arab Republic?
Your response must be concise. -6.20e+06. In the year 1976, what is the difference between the Aid flow from UN agencies (US$) of Latin America(developing only) and Aid flow from UN agencies (US$) of Middle income?
Make the answer very short. -1.72e+08. In the year 1976, what is the difference between the Aid flow from UN agencies (US$) of Latin America(developing only) and Aid flow from UN agencies (US$) of Cameroon?
Your answer should be very brief. 2.68e+07. In the year 1976, what is the difference between the Aid flow from UN agencies (US$) of Latin America(developing only) and Aid flow from UN agencies (US$) of Syrian Arab Republic?
Make the answer very short. 2.10e+07. In the year 1976, what is the difference between the Aid flow from UN agencies (US$) of Middle income and Aid flow from UN agencies (US$) of Cameroon?
Give a very brief answer. 1.99e+08. In the year 1976, what is the difference between the Aid flow from UN agencies (US$) in Middle income and Aid flow from UN agencies (US$) in Syrian Arab Republic?
Ensure brevity in your answer.  1.94e+08. In the year 1976, what is the difference between the Aid flow from UN agencies (US$) in Cameroon and Aid flow from UN agencies (US$) in Syrian Arab Republic?
Give a very brief answer. -5.77e+06. In the year 1977, what is the difference between the Aid flow from UN agencies (US$) of Latin America(developing only) and Aid flow from UN agencies (US$) of Middle income?
Give a very brief answer. -2.30e+08. In the year 1977, what is the difference between the Aid flow from UN agencies (US$) of Latin America(developing only) and Aid flow from UN agencies (US$) of Cameroon?
Make the answer very short. 3.35e+07. In the year 1977, what is the difference between the Aid flow from UN agencies (US$) in Latin America(developing only) and Aid flow from UN agencies (US$) in Syrian Arab Republic?
Offer a terse response. 2.03e+07. In the year 1977, what is the difference between the Aid flow from UN agencies (US$) in Middle income and Aid flow from UN agencies (US$) in Cameroon?
Your answer should be compact. 2.64e+08. In the year 1977, what is the difference between the Aid flow from UN agencies (US$) of Middle income and Aid flow from UN agencies (US$) of Syrian Arab Republic?
Offer a very short reply. 2.51e+08. In the year 1977, what is the difference between the Aid flow from UN agencies (US$) in Cameroon and Aid flow from UN agencies (US$) in Syrian Arab Republic?
Keep it short and to the point. -1.32e+07. What is the ratio of the Aid flow from UN agencies (US$) in Latin America(developing only) in 1971 to that in 1972?
Your response must be concise. 0.71. What is the ratio of the Aid flow from UN agencies (US$) in Middle income in 1971 to that in 1972?
Your answer should be compact. 1.29. What is the ratio of the Aid flow from UN agencies (US$) of Syrian Arab Republic in 1971 to that in 1972?
Your answer should be compact. 1.06. What is the ratio of the Aid flow from UN agencies (US$) of Latin America(developing only) in 1971 to that in 1973?
Provide a succinct answer. 0.6. What is the ratio of the Aid flow from UN agencies (US$) in Middle income in 1971 to that in 1973?
Ensure brevity in your answer.  0.84. What is the ratio of the Aid flow from UN agencies (US$) in Cameroon in 1971 to that in 1973?
Make the answer very short. 0.75. What is the ratio of the Aid flow from UN agencies (US$) of Syrian Arab Republic in 1971 to that in 1973?
Offer a terse response. 1.24. What is the ratio of the Aid flow from UN agencies (US$) in Latin America(developing only) in 1971 to that in 1974?
Your answer should be compact. 0.66. What is the ratio of the Aid flow from UN agencies (US$) of Middle income in 1971 to that in 1974?
Offer a very short reply. 0.7. What is the ratio of the Aid flow from UN agencies (US$) of Syrian Arab Republic in 1971 to that in 1974?
Provide a short and direct response. 1.05. What is the ratio of the Aid flow from UN agencies (US$) in Latin America(developing only) in 1971 to that in 1975?
Make the answer very short. 0.57. What is the ratio of the Aid flow from UN agencies (US$) in Middle income in 1971 to that in 1975?
Provide a short and direct response. 0.4. What is the ratio of the Aid flow from UN agencies (US$) in Cameroon in 1971 to that in 1975?
Offer a very short reply. 0.11. What is the ratio of the Aid flow from UN agencies (US$) in Syrian Arab Republic in 1971 to that in 1975?
Make the answer very short. 0.64. What is the ratio of the Aid flow from UN agencies (US$) of Latin America(developing only) in 1971 to that in 1976?
Provide a short and direct response. 0.51. What is the ratio of the Aid flow from UN agencies (US$) of Middle income in 1971 to that in 1976?
Give a very brief answer. 0.61. What is the ratio of the Aid flow from UN agencies (US$) in Cameroon in 1971 to that in 1976?
Give a very brief answer. 0.05. What is the ratio of the Aid flow from UN agencies (US$) in Syrian Arab Republic in 1971 to that in 1976?
Your answer should be compact. 0.59. What is the ratio of the Aid flow from UN agencies (US$) of Latin America(developing only) in 1971 to that in 1977?
Your answer should be very brief. 0.43. What is the ratio of the Aid flow from UN agencies (US$) in Middle income in 1971 to that in 1977?
Your answer should be compact. 0.46. What is the ratio of the Aid flow from UN agencies (US$) in Cameroon in 1971 to that in 1977?
Provide a short and direct response. 1.5. What is the ratio of the Aid flow from UN agencies (US$) in Syrian Arab Republic in 1971 to that in 1977?
Your response must be concise. 0.34. What is the ratio of the Aid flow from UN agencies (US$) in Latin America(developing only) in 1972 to that in 1973?
Offer a very short reply. 0.85. What is the ratio of the Aid flow from UN agencies (US$) of Middle income in 1972 to that in 1973?
Ensure brevity in your answer.  0.65. What is the ratio of the Aid flow from UN agencies (US$) of Syrian Arab Republic in 1972 to that in 1973?
Provide a succinct answer. 1.16. What is the ratio of the Aid flow from UN agencies (US$) of Latin America(developing only) in 1972 to that in 1974?
Offer a terse response. 0.92. What is the ratio of the Aid flow from UN agencies (US$) of Middle income in 1972 to that in 1974?
Your answer should be very brief. 0.54. What is the ratio of the Aid flow from UN agencies (US$) of Cameroon in 1972 to that in 1974?
Offer a terse response. 0.44. What is the ratio of the Aid flow from UN agencies (US$) of Syrian Arab Republic in 1972 to that in 1974?
Make the answer very short. 0.98. What is the ratio of the Aid flow from UN agencies (US$) of Latin America(developing only) in 1972 to that in 1975?
Your response must be concise. 0.8. What is the ratio of the Aid flow from UN agencies (US$) of Middle income in 1972 to that in 1975?
Make the answer very short. 0.31. What is the ratio of the Aid flow from UN agencies (US$) of Cameroon in 1972 to that in 1975?
Make the answer very short. 0.28. What is the ratio of the Aid flow from UN agencies (US$) of Syrian Arab Republic in 1972 to that in 1975?
Your answer should be very brief. 0.6. What is the ratio of the Aid flow from UN agencies (US$) in Latin America(developing only) in 1972 to that in 1976?
Offer a terse response. 0.71. What is the ratio of the Aid flow from UN agencies (US$) in Middle income in 1972 to that in 1976?
Provide a succinct answer. 0.47. What is the ratio of the Aid flow from UN agencies (US$) in Cameroon in 1972 to that in 1976?
Provide a succinct answer. 0.13. What is the ratio of the Aid flow from UN agencies (US$) of Syrian Arab Republic in 1972 to that in 1976?
Offer a terse response. 0.55. What is the ratio of the Aid flow from UN agencies (US$) of Latin America(developing only) in 1972 to that in 1977?
Your response must be concise. 0.61. What is the ratio of the Aid flow from UN agencies (US$) in Middle income in 1972 to that in 1977?
Offer a very short reply. 0.36. What is the ratio of the Aid flow from UN agencies (US$) in Syrian Arab Republic in 1972 to that in 1977?
Your answer should be compact. 0.32. What is the ratio of the Aid flow from UN agencies (US$) of Latin America(developing only) in 1973 to that in 1974?
Offer a very short reply. 1.09. What is the ratio of the Aid flow from UN agencies (US$) in Middle income in 1973 to that in 1974?
Provide a succinct answer. 0.84. What is the ratio of the Aid flow from UN agencies (US$) in Cameroon in 1973 to that in 1974?
Your answer should be compact. 0.22. What is the ratio of the Aid flow from UN agencies (US$) in Syrian Arab Republic in 1973 to that in 1974?
Give a very brief answer. 0.85. What is the ratio of the Aid flow from UN agencies (US$) in Latin America(developing only) in 1973 to that in 1975?
Ensure brevity in your answer.  0.94. What is the ratio of the Aid flow from UN agencies (US$) of Middle income in 1973 to that in 1975?
Provide a short and direct response. 0.47. What is the ratio of the Aid flow from UN agencies (US$) in Cameroon in 1973 to that in 1975?
Your answer should be compact. 0.14. What is the ratio of the Aid flow from UN agencies (US$) in Syrian Arab Republic in 1973 to that in 1975?
Give a very brief answer. 0.52. What is the ratio of the Aid flow from UN agencies (US$) of Latin America(developing only) in 1973 to that in 1976?
Provide a succinct answer. 0.84. What is the ratio of the Aid flow from UN agencies (US$) in Middle income in 1973 to that in 1976?
Your answer should be compact. 0.72. What is the ratio of the Aid flow from UN agencies (US$) in Cameroon in 1973 to that in 1976?
Offer a very short reply. 0.06. What is the ratio of the Aid flow from UN agencies (US$) of Syrian Arab Republic in 1973 to that in 1976?
Make the answer very short. 0.48. What is the ratio of the Aid flow from UN agencies (US$) of Latin America(developing only) in 1973 to that in 1977?
Provide a short and direct response. 0.72. What is the ratio of the Aid flow from UN agencies (US$) in Middle income in 1973 to that in 1977?
Provide a short and direct response. 0.55. What is the ratio of the Aid flow from UN agencies (US$) in Syrian Arab Republic in 1973 to that in 1977?
Give a very brief answer. 0.28. What is the ratio of the Aid flow from UN agencies (US$) of Latin America(developing only) in 1974 to that in 1975?
Your answer should be very brief. 0.87. What is the ratio of the Aid flow from UN agencies (US$) in Middle income in 1974 to that in 1975?
Ensure brevity in your answer.  0.57. What is the ratio of the Aid flow from UN agencies (US$) in Cameroon in 1974 to that in 1975?
Make the answer very short. 0.64. What is the ratio of the Aid flow from UN agencies (US$) in Syrian Arab Republic in 1974 to that in 1975?
Provide a short and direct response. 0.61. What is the ratio of the Aid flow from UN agencies (US$) of Latin America(developing only) in 1974 to that in 1976?
Make the answer very short. 0.77. What is the ratio of the Aid flow from UN agencies (US$) of Middle income in 1974 to that in 1976?
Offer a very short reply. 0.86. What is the ratio of the Aid flow from UN agencies (US$) of Cameroon in 1974 to that in 1976?
Give a very brief answer. 0.28. What is the ratio of the Aid flow from UN agencies (US$) of Syrian Arab Republic in 1974 to that in 1976?
Give a very brief answer. 0.56. What is the ratio of the Aid flow from UN agencies (US$) of Latin America(developing only) in 1974 to that in 1977?
Your answer should be very brief. 0.66. What is the ratio of the Aid flow from UN agencies (US$) of Middle income in 1974 to that in 1977?
Provide a succinct answer. 0.66. What is the ratio of the Aid flow from UN agencies (US$) in Syrian Arab Republic in 1974 to that in 1977?
Your answer should be very brief. 0.33. What is the ratio of the Aid flow from UN agencies (US$) in Latin America(developing only) in 1975 to that in 1976?
Keep it short and to the point. 0.89. What is the ratio of the Aid flow from UN agencies (US$) of Middle income in 1975 to that in 1976?
Your response must be concise. 1.53. What is the ratio of the Aid flow from UN agencies (US$) in Cameroon in 1975 to that in 1976?
Provide a succinct answer. 0.45. What is the ratio of the Aid flow from UN agencies (US$) of Syrian Arab Republic in 1975 to that in 1976?
Ensure brevity in your answer.  0.92. What is the ratio of the Aid flow from UN agencies (US$) of Latin America(developing only) in 1975 to that in 1977?
Provide a succinct answer. 0.76. What is the ratio of the Aid flow from UN agencies (US$) of Middle income in 1975 to that in 1977?
Keep it short and to the point. 1.17. What is the ratio of the Aid flow from UN agencies (US$) of Cameroon in 1975 to that in 1977?
Offer a very short reply. 14.17. What is the ratio of the Aid flow from UN agencies (US$) of Syrian Arab Republic in 1975 to that in 1977?
Your answer should be very brief. 0.53. What is the ratio of the Aid flow from UN agencies (US$) of Latin America(developing only) in 1976 to that in 1977?
Give a very brief answer. 0.86. What is the ratio of the Aid flow from UN agencies (US$) of Middle income in 1976 to that in 1977?
Provide a short and direct response. 0.76. What is the ratio of the Aid flow from UN agencies (US$) in Cameroon in 1976 to that in 1977?
Your response must be concise. 31.83. What is the ratio of the Aid flow from UN agencies (US$) of Syrian Arab Republic in 1976 to that in 1977?
Keep it short and to the point. 0.58. What is the difference between the highest and the second highest Aid flow from UN agencies (US$) of Latin America(developing only)?
Your answer should be very brief. 4.84e+06. What is the difference between the highest and the second highest Aid flow from UN agencies (US$) in Middle income?
Ensure brevity in your answer.  4.35e+07. What is the difference between the highest and the second highest Aid flow from UN agencies (US$) of Cameroon?
Your answer should be compact. 1.06e+06. What is the difference between the highest and the second highest Aid flow from UN agencies (US$) in Syrian Arab Republic?
Provide a short and direct response. 5.57e+06. What is the difference between the highest and the lowest Aid flow from UN agencies (US$) in Latin America(developing only)?
Make the answer very short. 1.90e+07. What is the difference between the highest and the lowest Aid flow from UN agencies (US$) in Middle income?
Keep it short and to the point. 2.13e+08. What is the difference between the highest and the lowest Aid flow from UN agencies (US$) of Cameroon?
Offer a very short reply. 1.85e+06. What is the difference between the highest and the lowest Aid flow from UN agencies (US$) of Syrian Arab Republic?
Your answer should be very brief. 9.59e+06. 